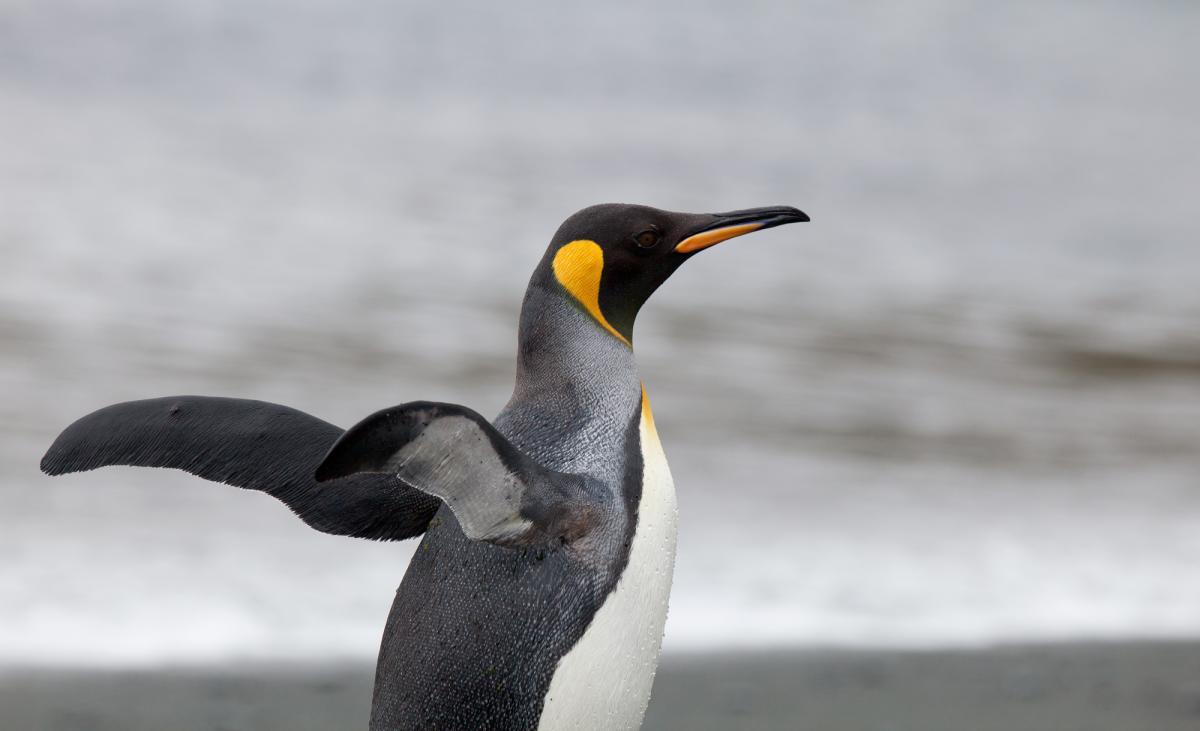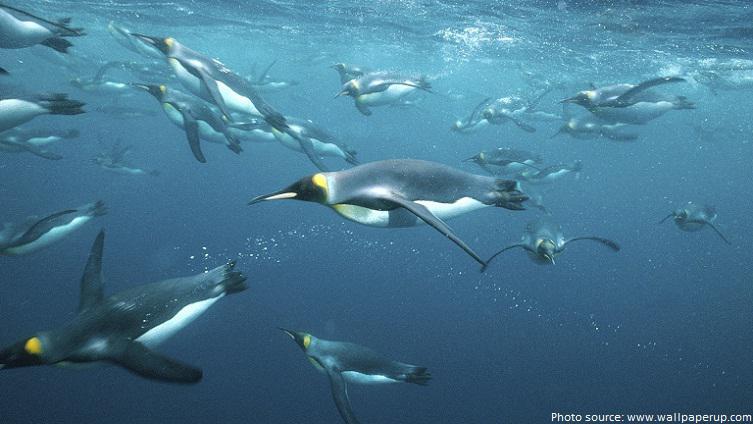The first image is the image on the left, the second image is the image on the right. Given the left and right images, does the statement "An image shows multiple penguins swimming underwater where no ocean bottom is visible." hold true? Answer yes or no. Yes. The first image is the image on the left, the second image is the image on the right. Evaluate the accuracy of this statement regarding the images: "There are no more than 2 penguins in one of the images.". Is it true? Answer yes or no. Yes. 